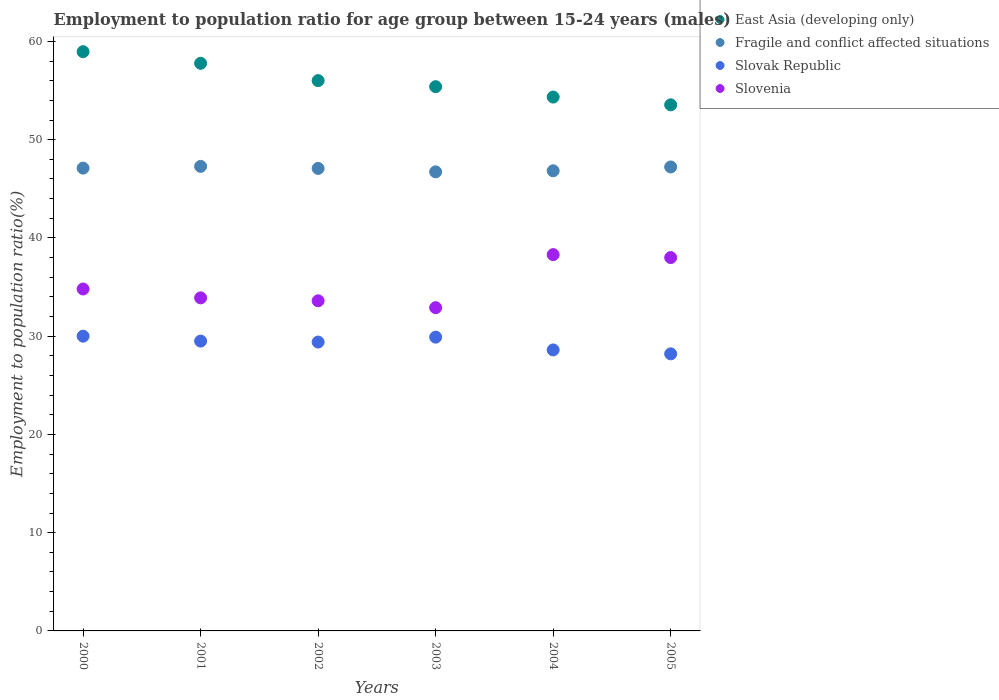What is the employment to population ratio in Slovenia in 2003?
Your response must be concise. 32.9. Across all years, what is the maximum employment to population ratio in Slovenia?
Provide a succinct answer. 38.3. Across all years, what is the minimum employment to population ratio in East Asia (developing only)?
Your answer should be very brief. 53.55. In which year was the employment to population ratio in Fragile and conflict affected situations maximum?
Your answer should be very brief. 2001. What is the total employment to population ratio in Slovenia in the graph?
Your response must be concise. 211.5. What is the difference between the employment to population ratio in Slovak Republic in 2001 and that in 2005?
Offer a very short reply. 1.3. What is the difference between the employment to population ratio in Slovak Republic in 2000 and the employment to population ratio in East Asia (developing only) in 2005?
Keep it short and to the point. -23.55. What is the average employment to population ratio in Slovak Republic per year?
Your response must be concise. 29.27. In the year 2002, what is the difference between the employment to population ratio in East Asia (developing only) and employment to population ratio in Slovenia?
Provide a short and direct response. 22.41. In how many years, is the employment to population ratio in Fragile and conflict affected situations greater than 44 %?
Ensure brevity in your answer.  6. What is the ratio of the employment to population ratio in Slovenia in 2000 to that in 2001?
Offer a very short reply. 1.03. Is the employment to population ratio in Fragile and conflict affected situations in 2000 less than that in 2004?
Your answer should be compact. No. Is the difference between the employment to population ratio in East Asia (developing only) in 2002 and 2005 greater than the difference between the employment to population ratio in Slovenia in 2002 and 2005?
Keep it short and to the point. Yes. What is the difference between the highest and the second highest employment to population ratio in Fragile and conflict affected situations?
Offer a terse response. 0.06. What is the difference between the highest and the lowest employment to population ratio in Slovenia?
Offer a very short reply. 5.4. Is the employment to population ratio in East Asia (developing only) strictly greater than the employment to population ratio in Slovak Republic over the years?
Offer a terse response. Yes. Does the graph contain grids?
Offer a very short reply. No. Where does the legend appear in the graph?
Your answer should be very brief. Top right. How many legend labels are there?
Give a very brief answer. 4. What is the title of the graph?
Your answer should be compact. Employment to population ratio for age group between 15-24 years (males). Does "Vietnam" appear as one of the legend labels in the graph?
Give a very brief answer. No. What is the label or title of the Y-axis?
Give a very brief answer. Employment to population ratio(%). What is the Employment to population ratio(%) of East Asia (developing only) in 2000?
Your answer should be very brief. 58.95. What is the Employment to population ratio(%) in Fragile and conflict affected situations in 2000?
Your answer should be compact. 47.1. What is the Employment to population ratio(%) of Slovenia in 2000?
Keep it short and to the point. 34.8. What is the Employment to population ratio(%) of East Asia (developing only) in 2001?
Keep it short and to the point. 57.77. What is the Employment to population ratio(%) in Fragile and conflict affected situations in 2001?
Ensure brevity in your answer.  47.28. What is the Employment to population ratio(%) of Slovak Republic in 2001?
Give a very brief answer. 29.5. What is the Employment to population ratio(%) of Slovenia in 2001?
Offer a terse response. 33.9. What is the Employment to population ratio(%) in East Asia (developing only) in 2002?
Your answer should be very brief. 56.01. What is the Employment to population ratio(%) in Fragile and conflict affected situations in 2002?
Keep it short and to the point. 47.07. What is the Employment to population ratio(%) of Slovak Republic in 2002?
Your answer should be very brief. 29.4. What is the Employment to population ratio(%) of Slovenia in 2002?
Make the answer very short. 33.6. What is the Employment to population ratio(%) of East Asia (developing only) in 2003?
Your response must be concise. 55.39. What is the Employment to population ratio(%) in Fragile and conflict affected situations in 2003?
Offer a terse response. 46.72. What is the Employment to population ratio(%) of Slovak Republic in 2003?
Give a very brief answer. 29.9. What is the Employment to population ratio(%) in Slovenia in 2003?
Give a very brief answer. 32.9. What is the Employment to population ratio(%) of East Asia (developing only) in 2004?
Provide a succinct answer. 54.34. What is the Employment to population ratio(%) of Fragile and conflict affected situations in 2004?
Provide a succinct answer. 46.83. What is the Employment to population ratio(%) in Slovak Republic in 2004?
Keep it short and to the point. 28.6. What is the Employment to population ratio(%) of Slovenia in 2004?
Provide a succinct answer. 38.3. What is the Employment to population ratio(%) of East Asia (developing only) in 2005?
Offer a terse response. 53.55. What is the Employment to population ratio(%) of Fragile and conflict affected situations in 2005?
Your answer should be compact. 47.22. What is the Employment to population ratio(%) of Slovak Republic in 2005?
Your answer should be compact. 28.2. What is the Employment to population ratio(%) in Slovenia in 2005?
Make the answer very short. 38. Across all years, what is the maximum Employment to population ratio(%) in East Asia (developing only)?
Give a very brief answer. 58.95. Across all years, what is the maximum Employment to population ratio(%) of Fragile and conflict affected situations?
Your answer should be very brief. 47.28. Across all years, what is the maximum Employment to population ratio(%) in Slovak Republic?
Provide a short and direct response. 30. Across all years, what is the maximum Employment to population ratio(%) in Slovenia?
Your response must be concise. 38.3. Across all years, what is the minimum Employment to population ratio(%) of East Asia (developing only)?
Make the answer very short. 53.55. Across all years, what is the minimum Employment to population ratio(%) in Fragile and conflict affected situations?
Offer a very short reply. 46.72. Across all years, what is the minimum Employment to population ratio(%) in Slovak Republic?
Ensure brevity in your answer.  28.2. Across all years, what is the minimum Employment to population ratio(%) of Slovenia?
Your response must be concise. 32.9. What is the total Employment to population ratio(%) in East Asia (developing only) in the graph?
Provide a short and direct response. 336.01. What is the total Employment to population ratio(%) in Fragile and conflict affected situations in the graph?
Make the answer very short. 282.24. What is the total Employment to population ratio(%) of Slovak Republic in the graph?
Give a very brief answer. 175.6. What is the total Employment to population ratio(%) in Slovenia in the graph?
Make the answer very short. 211.5. What is the difference between the Employment to population ratio(%) of East Asia (developing only) in 2000 and that in 2001?
Keep it short and to the point. 1.18. What is the difference between the Employment to population ratio(%) in Fragile and conflict affected situations in 2000 and that in 2001?
Provide a short and direct response. -0.18. What is the difference between the Employment to population ratio(%) of Slovak Republic in 2000 and that in 2001?
Offer a terse response. 0.5. What is the difference between the Employment to population ratio(%) of East Asia (developing only) in 2000 and that in 2002?
Offer a very short reply. 2.95. What is the difference between the Employment to population ratio(%) of Fragile and conflict affected situations in 2000 and that in 2002?
Your response must be concise. 0.03. What is the difference between the Employment to population ratio(%) of Slovenia in 2000 and that in 2002?
Make the answer very short. 1.2. What is the difference between the Employment to population ratio(%) of East Asia (developing only) in 2000 and that in 2003?
Ensure brevity in your answer.  3.56. What is the difference between the Employment to population ratio(%) of Fragile and conflict affected situations in 2000 and that in 2003?
Give a very brief answer. 0.38. What is the difference between the Employment to population ratio(%) in Slovenia in 2000 and that in 2003?
Ensure brevity in your answer.  1.9. What is the difference between the Employment to population ratio(%) in East Asia (developing only) in 2000 and that in 2004?
Make the answer very short. 4.62. What is the difference between the Employment to population ratio(%) of Fragile and conflict affected situations in 2000 and that in 2004?
Offer a very short reply. 0.27. What is the difference between the Employment to population ratio(%) of East Asia (developing only) in 2000 and that in 2005?
Give a very brief answer. 5.41. What is the difference between the Employment to population ratio(%) of Fragile and conflict affected situations in 2000 and that in 2005?
Make the answer very short. -0.12. What is the difference between the Employment to population ratio(%) of Slovak Republic in 2000 and that in 2005?
Give a very brief answer. 1.8. What is the difference between the Employment to population ratio(%) in East Asia (developing only) in 2001 and that in 2002?
Your answer should be compact. 1.76. What is the difference between the Employment to population ratio(%) in Fragile and conflict affected situations in 2001 and that in 2002?
Make the answer very short. 0.21. What is the difference between the Employment to population ratio(%) of Slovenia in 2001 and that in 2002?
Offer a very short reply. 0.3. What is the difference between the Employment to population ratio(%) of East Asia (developing only) in 2001 and that in 2003?
Keep it short and to the point. 2.38. What is the difference between the Employment to population ratio(%) in Fragile and conflict affected situations in 2001 and that in 2003?
Ensure brevity in your answer.  0.56. What is the difference between the Employment to population ratio(%) in Slovak Republic in 2001 and that in 2003?
Keep it short and to the point. -0.4. What is the difference between the Employment to population ratio(%) in East Asia (developing only) in 2001 and that in 2004?
Offer a very short reply. 3.43. What is the difference between the Employment to population ratio(%) of Fragile and conflict affected situations in 2001 and that in 2004?
Your answer should be compact. 0.45. What is the difference between the Employment to population ratio(%) in East Asia (developing only) in 2001 and that in 2005?
Offer a terse response. 4.23. What is the difference between the Employment to population ratio(%) in Fragile and conflict affected situations in 2001 and that in 2005?
Your answer should be compact. 0.06. What is the difference between the Employment to population ratio(%) in Slovak Republic in 2001 and that in 2005?
Make the answer very short. 1.3. What is the difference between the Employment to population ratio(%) of Slovenia in 2001 and that in 2005?
Offer a terse response. -4.1. What is the difference between the Employment to population ratio(%) in East Asia (developing only) in 2002 and that in 2003?
Give a very brief answer. 0.62. What is the difference between the Employment to population ratio(%) of Fragile and conflict affected situations in 2002 and that in 2003?
Offer a very short reply. 0.35. What is the difference between the Employment to population ratio(%) of Slovenia in 2002 and that in 2003?
Give a very brief answer. 0.7. What is the difference between the Employment to population ratio(%) in East Asia (developing only) in 2002 and that in 2004?
Give a very brief answer. 1.67. What is the difference between the Employment to population ratio(%) of Fragile and conflict affected situations in 2002 and that in 2004?
Provide a succinct answer. 0.24. What is the difference between the Employment to population ratio(%) of Slovak Republic in 2002 and that in 2004?
Offer a very short reply. 0.8. What is the difference between the Employment to population ratio(%) of East Asia (developing only) in 2002 and that in 2005?
Give a very brief answer. 2.46. What is the difference between the Employment to population ratio(%) of Fragile and conflict affected situations in 2002 and that in 2005?
Make the answer very short. -0.15. What is the difference between the Employment to population ratio(%) of East Asia (developing only) in 2003 and that in 2004?
Offer a very short reply. 1.06. What is the difference between the Employment to population ratio(%) in Fragile and conflict affected situations in 2003 and that in 2004?
Keep it short and to the point. -0.11. What is the difference between the Employment to population ratio(%) of Slovenia in 2003 and that in 2004?
Offer a terse response. -5.4. What is the difference between the Employment to population ratio(%) in East Asia (developing only) in 2003 and that in 2005?
Ensure brevity in your answer.  1.85. What is the difference between the Employment to population ratio(%) of Fragile and conflict affected situations in 2003 and that in 2005?
Provide a short and direct response. -0.5. What is the difference between the Employment to population ratio(%) of Slovak Republic in 2003 and that in 2005?
Provide a short and direct response. 1.7. What is the difference between the Employment to population ratio(%) of Slovenia in 2003 and that in 2005?
Make the answer very short. -5.1. What is the difference between the Employment to population ratio(%) of East Asia (developing only) in 2004 and that in 2005?
Give a very brief answer. 0.79. What is the difference between the Employment to population ratio(%) of Fragile and conflict affected situations in 2004 and that in 2005?
Provide a succinct answer. -0.39. What is the difference between the Employment to population ratio(%) in Slovak Republic in 2004 and that in 2005?
Give a very brief answer. 0.4. What is the difference between the Employment to population ratio(%) in Slovenia in 2004 and that in 2005?
Give a very brief answer. 0.3. What is the difference between the Employment to population ratio(%) of East Asia (developing only) in 2000 and the Employment to population ratio(%) of Fragile and conflict affected situations in 2001?
Provide a succinct answer. 11.67. What is the difference between the Employment to population ratio(%) in East Asia (developing only) in 2000 and the Employment to population ratio(%) in Slovak Republic in 2001?
Give a very brief answer. 29.45. What is the difference between the Employment to population ratio(%) of East Asia (developing only) in 2000 and the Employment to population ratio(%) of Slovenia in 2001?
Keep it short and to the point. 25.05. What is the difference between the Employment to population ratio(%) of Fragile and conflict affected situations in 2000 and the Employment to population ratio(%) of Slovak Republic in 2001?
Your answer should be very brief. 17.6. What is the difference between the Employment to population ratio(%) of Fragile and conflict affected situations in 2000 and the Employment to population ratio(%) of Slovenia in 2001?
Your answer should be compact. 13.2. What is the difference between the Employment to population ratio(%) of Slovak Republic in 2000 and the Employment to population ratio(%) of Slovenia in 2001?
Your response must be concise. -3.9. What is the difference between the Employment to population ratio(%) in East Asia (developing only) in 2000 and the Employment to population ratio(%) in Fragile and conflict affected situations in 2002?
Keep it short and to the point. 11.88. What is the difference between the Employment to population ratio(%) of East Asia (developing only) in 2000 and the Employment to population ratio(%) of Slovak Republic in 2002?
Offer a very short reply. 29.55. What is the difference between the Employment to population ratio(%) of East Asia (developing only) in 2000 and the Employment to population ratio(%) of Slovenia in 2002?
Provide a succinct answer. 25.35. What is the difference between the Employment to population ratio(%) in Fragile and conflict affected situations in 2000 and the Employment to population ratio(%) in Slovak Republic in 2002?
Make the answer very short. 17.7. What is the difference between the Employment to population ratio(%) in Fragile and conflict affected situations in 2000 and the Employment to population ratio(%) in Slovenia in 2002?
Your response must be concise. 13.5. What is the difference between the Employment to population ratio(%) of East Asia (developing only) in 2000 and the Employment to population ratio(%) of Fragile and conflict affected situations in 2003?
Offer a terse response. 12.23. What is the difference between the Employment to population ratio(%) of East Asia (developing only) in 2000 and the Employment to population ratio(%) of Slovak Republic in 2003?
Provide a short and direct response. 29.05. What is the difference between the Employment to population ratio(%) in East Asia (developing only) in 2000 and the Employment to population ratio(%) in Slovenia in 2003?
Keep it short and to the point. 26.05. What is the difference between the Employment to population ratio(%) in Fragile and conflict affected situations in 2000 and the Employment to population ratio(%) in Slovak Republic in 2003?
Keep it short and to the point. 17.2. What is the difference between the Employment to population ratio(%) in Fragile and conflict affected situations in 2000 and the Employment to population ratio(%) in Slovenia in 2003?
Your answer should be very brief. 14.2. What is the difference between the Employment to population ratio(%) of Slovak Republic in 2000 and the Employment to population ratio(%) of Slovenia in 2003?
Give a very brief answer. -2.9. What is the difference between the Employment to population ratio(%) of East Asia (developing only) in 2000 and the Employment to population ratio(%) of Fragile and conflict affected situations in 2004?
Provide a succinct answer. 12.12. What is the difference between the Employment to population ratio(%) of East Asia (developing only) in 2000 and the Employment to population ratio(%) of Slovak Republic in 2004?
Give a very brief answer. 30.35. What is the difference between the Employment to population ratio(%) in East Asia (developing only) in 2000 and the Employment to population ratio(%) in Slovenia in 2004?
Your answer should be compact. 20.65. What is the difference between the Employment to population ratio(%) in Fragile and conflict affected situations in 2000 and the Employment to population ratio(%) in Slovak Republic in 2004?
Keep it short and to the point. 18.5. What is the difference between the Employment to population ratio(%) of Fragile and conflict affected situations in 2000 and the Employment to population ratio(%) of Slovenia in 2004?
Your answer should be compact. 8.8. What is the difference between the Employment to population ratio(%) in Slovak Republic in 2000 and the Employment to population ratio(%) in Slovenia in 2004?
Offer a terse response. -8.3. What is the difference between the Employment to population ratio(%) in East Asia (developing only) in 2000 and the Employment to population ratio(%) in Fragile and conflict affected situations in 2005?
Provide a succinct answer. 11.73. What is the difference between the Employment to population ratio(%) in East Asia (developing only) in 2000 and the Employment to population ratio(%) in Slovak Republic in 2005?
Your response must be concise. 30.75. What is the difference between the Employment to population ratio(%) of East Asia (developing only) in 2000 and the Employment to population ratio(%) of Slovenia in 2005?
Your answer should be compact. 20.95. What is the difference between the Employment to population ratio(%) in Fragile and conflict affected situations in 2000 and the Employment to population ratio(%) in Slovak Republic in 2005?
Provide a succinct answer. 18.9. What is the difference between the Employment to population ratio(%) in Fragile and conflict affected situations in 2000 and the Employment to population ratio(%) in Slovenia in 2005?
Keep it short and to the point. 9.1. What is the difference between the Employment to population ratio(%) in Slovak Republic in 2000 and the Employment to population ratio(%) in Slovenia in 2005?
Offer a very short reply. -8. What is the difference between the Employment to population ratio(%) of East Asia (developing only) in 2001 and the Employment to population ratio(%) of Fragile and conflict affected situations in 2002?
Make the answer very short. 10.7. What is the difference between the Employment to population ratio(%) in East Asia (developing only) in 2001 and the Employment to population ratio(%) in Slovak Republic in 2002?
Give a very brief answer. 28.37. What is the difference between the Employment to population ratio(%) in East Asia (developing only) in 2001 and the Employment to population ratio(%) in Slovenia in 2002?
Ensure brevity in your answer.  24.17. What is the difference between the Employment to population ratio(%) in Fragile and conflict affected situations in 2001 and the Employment to population ratio(%) in Slovak Republic in 2002?
Your response must be concise. 17.88. What is the difference between the Employment to population ratio(%) in Fragile and conflict affected situations in 2001 and the Employment to population ratio(%) in Slovenia in 2002?
Provide a short and direct response. 13.68. What is the difference between the Employment to population ratio(%) of Slovak Republic in 2001 and the Employment to population ratio(%) of Slovenia in 2002?
Keep it short and to the point. -4.1. What is the difference between the Employment to population ratio(%) in East Asia (developing only) in 2001 and the Employment to population ratio(%) in Fragile and conflict affected situations in 2003?
Provide a short and direct response. 11.05. What is the difference between the Employment to population ratio(%) in East Asia (developing only) in 2001 and the Employment to population ratio(%) in Slovak Republic in 2003?
Your answer should be very brief. 27.87. What is the difference between the Employment to population ratio(%) in East Asia (developing only) in 2001 and the Employment to population ratio(%) in Slovenia in 2003?
Provide a succinct answer. 24.87. What is the difference between the Employment to population ratio(%) of Fragile and conflict affected situations in 2001 and the Employment to population ratio(%) of Slovak Republic in 2003?
Keep it short and to the point. 17.38. What is the difference between the Employment to population ratio(%) of Fragile and conflict affected situations in 2001 and the Employment to population ratio(%) of Slovenia in 2003?
Keep it short and to the point. 14.38. What is the difference between the Employment to population ratio(%) of Slovak Republic in 2001 and the Employment to population ratio(%) of Slovenia in 2003?
Ensure brevity in your answer.  -3.4. What is the difference between the Employment to population ratio(%) in East Asia (developing only) in 2001 and the Employment to population ratio(%) in Fragile and conflict affected situations in 2004?
Ensure brevity in your answer.  10.94. What is the difference between the Employment to population ratio(%) in East Asia (developing only) in 2001 and the Employment to population ratio(%) in Slovak Republic in 2004?
Make the answer very short. 29.17. What is the difference between the Employment to population ratio(%) of East Asia (developing only) in 2001 and the Employment to population ratio(%) of Slovenia in 2004?
Make the answer very short. 19.47. What is the difference between the Employment to population ratio(%) of Fragile and conflict affected situations in 2001 and the Employment to population ratio(%) of Slovak Republic in 2004?
Provide a succinct answer. 18.68. What is the difference between the Employment to population ratio(%) in Fragile and conflict affected situations in 2001 and the Employment to population ratio(%) in Slovenia in 2004?
Ensure brevity in your answer.  8.98. What is the difference between the Employment to population ratio(%) in Slovak Republic in 2001 and the Employment to population ratio(%) in Slovenia in 2004?
Your answer should be very brief. -8.8. What is the difference between the Employment to population ratio(%) in East Asia (developing only) in 2001 and the Employment to population ratio(%) in Fragile and conflict affected situations in 2005?
Offer a terse response. 10.55. What is the difference between the Employment to population ratio(%) in East Asia (developing only) in 2001 and the Employment to population ratio(%) in Slovak Republic in 2005?
Offer a terse response. 29.57. What is the difference between the Employment to population ratio(%) in East Asia (developing only) in 2001 and the Employment to population ratio(%) in Slovenia in 2005?
Offer a terse response. 19.77. What is the difference between the Employment to population ratio(%) of Fragile and conflict affected situations in 2001 and the Employment to population ratio(%) of Slovak Republic in 2005?
Provide a short and direct response. 19.08. What is the difference between the Employment to population ratio(%) in Fragile and conflict affected situations in 2001 and the Employment to population ratio(%) in Slovenia in 2005?
Give a very brief answer. 9.28. What is the difference between the Employment to population ratio(%) in East Asia (developing only) in 2002 and the Employment to population ratio(%) in Fragile and conflict affected situations in 2003?
Provide a succinct answer. 9.29. What is the difference between the Employment to population ratio(%) of East Asia (developing only) in 2002 and the Employment to population ratio(%) of Slovak Republic in 2003?
Give a very brief answer. 26.11. What is the difference between the Employment to population ratio(%) of East Asia (developing only) in 2002 and the Employment to population ratio(%) of Slovenia in 2003?
Offer a very short reply. 23.11. What is the difference between the Employment to population ratio(%) in Fragile and conflict affected situations in 2002 and the Employment to population ratio(%) in Slovak Republic in 2003?
Provide a short and direct response. 17.17. What is the difference between the Employment to population ratio(%) of Fragile and conflict affected situations in 2002 and the Employment to population ratio(%) of Slovenia in 2003?
Keep it short and to the point. 14.17. What is the difference between the Employment to population ratio(%) in East Asia (developing only) in 2002 and the Employment to population ratio(%) in Fragile and conflict affected situations in 2004?
Keep it short and to the point. 9.18. What is the difference between the Employment to population ratio(%) of East Asia (developing only) in 2002 and the Employment to population ratio(%) of Slovak Republic in 2004?
Provide a short and direct response. 27.41. What is the difference between the Employment to population ratio(%) of East Asia (developing only) in 2002 and the Employment to population ratio(%) of Slovenia in 2004?
Offer a terse response. 17.71. What is the difference between the Employment to population ratio(%) of Fragile and conflict affected situations in 2002 and the Employment to population ratio(%) of Slovak Republic in 2004?
Make the answer very short. 18.47. What is the difference between the Employment to population ratio(%) in Fragile and conflict affected situations in 2002 and the Employment to population ratio(%) in Slovenia in 2004?
Offer a terse response. 8.77. What is the difference between the Employment to population ratio(%) of East Asia (developing only) in 2002 and the Employment to population ratio(%) of Fragile and conflict affected situations in 2005?
Your answer should be compact. 8.79. What is the difference between the Employment to population ratio(%) of East Asia (developing only) in 2002 and the Employment to population ratio(%) of Slovak Republic in 2005?
Your answer should be very brief. 27.81. What is the difference between the Employment to population ratio(%) of East Asia (developing only) in 2002 and the Employment to population ratio(%) of Slovenia in 2005?
Your answer should be compact. 18.01. What is the difference between the Employment to population ratio(%) of Fragile and conflict affected situations in 2002 and the Employment to population ratio(%) of Slovak Republic in 2005?
Give a very brief answer. 18.87. What is the difference between the Employment to population ratio(%) in Fragile and conflict affected situations in 2002 and the Employment to population ratio(%) in Slovenia in 2005?
Make the answer very short. 9.07. What is the difference between the Employment to population ratio(%) of East Asia (developing only) in 2003 and the Employment to population ratio(%) of Fragile and conflict affected situations in 2004?
Make the answer very short. 8.56. What is the difference between the Employment to population ratio(%) of East Asia (developing only) in 2003 and the Employment to population ratio(%) of Slovak Republic in 2004?
Offer a very short reply. 26.79. What is the difference between the Employment to population ratio(%) of East Asia (developing only) in 2003 and the Employment to population ratio(%) of Slovenia in 2004?
Offer a very short reply. 17.09. What is the difference between the Employment to population ratio(%) of Fragile and conflict affected situations in 2003 and the Employment to population ratio(%) of Slovak Republic in 2004?
Your answer should be very brief. 18.12. What is the difference between the Employment to population ratio(%) of Fragile and conflict affected situations in 2003 and the Employment to population ratio(%) of Slovenia in 2004?
Offer a terse response. 8.42. What is the difference between the Employment to population ratio(%) of East Asia (developing only) in 2003 and the Employment to population ratio(%) of Fragile and conflict affected situations in 2005?
Keep it short and to the point. 8.17. What is the difference between the Employment to population ratio(%) in East Asia (developing only) in 2003 and the Employment to population ratio(%) in Slovak Republic in 2005?
Ensure brevity in your answer.  27.19. What is the difference between the Employment to population ratio(%) in East Asia (developing only) in 2003 and the Employment to population ratio(%) in Slovenia in 2005?
Make the answer very short. 17.39. What is the difference between the Employment to population ratio(%) in Fragile and conflict affected situations in 2003 and the Employment to population ratio(%) in Slovak Republic in 2005?
Your answer should be very brief. 18.52. What is the difference between the Employment to population ratio(%) of Fragile and conflict affected situations in 2003 and the Employment to population ratio(%) of Slovenia in 2005?
Give a very brief answer. 8.72. What is the difference between the Employment to population ratio(%) of Slovak Republic in 2003 and the Employment to population ratio(%) of Slovenia in 2005?
Your answer should be very brief. -8.1. What is the difference between the Employment to population ratio(%) of East Asia (developing only) in 2004 and the Employment to population ratio(%) of Fragile and conflict affected situations in 2005?
Ensure brevity in your answer.  7.11. What is the difference between the Employment to population ratio(%) of East Asia (developing only) in 2004 and the Employment to population ratio(%) of Slovak Republic in 2005?
Your answer should be compact. 26.14. What is the difference between the Employment to population ratio(%) of East Asia (developing only) in 2004 and the Employment to population ratio(%) of Slovenia in 2005?
Provide a succinct answer. 16.34. What is the difference between the Employment to population ratio(%) in Fragile and conflict affected situations in 2004 and the Employment to population ratio(%) in Slovak Republic in 2005?
Your answer should be compact. 18.63. What is the difference between the Employment to population ratio(%) of Fragile and conflict affected situations in 2004 and the Employment to population ratio(%) of Slovenia in 2005?
Offer a terse response. 8.83. What is the average Employment to population ratio(%) in East Asia (developing only) per year?
Offer a very short reply. 56. What is the average Employment to population ratio(%) of Fragile and conflict affected situations per year?
Offer a terse response. 47.04. What is the average Employment to population ratio(%) in Slovak Republic per year?
Provide a short and direct response. 29.27. What is the average Employment to population ratio(%) in Slovenia per year?
Offer a terse response. 35.25. In the year 2000, what is the difference between the Employment to population ratio(%) of East Asia (developing only) and Employment to population ratio(%) of Fragile and conflict affected situations?
Your answer should be compact. 11.85. In the year 2000, what is the difference between the Employment to population ratio(%) in East Asia (developing only) and Employment to population ratio(%) in Slovak Republic?
Your answer should be very brief. 28.95. In the year 2000, what is the difference between the Employment to population ratio(%) in East Asia (developing only) and Employment to population ratio(%) in Slovenia?
Give a very brief answer. 24.15. In the year 2000, what is the difference between the Employment to population ratio(%) in Fragile and conflict affected situations and Employment to population ratio(%) in Slovak Republic?
Provide a succinct answer. 17.1. In the year 2000, what is the difference between the Employment to population ratio(%) of Fragile and conflict affected situations and Employment to population ratio(%) of Slovenia?
Provide a succinct answer. 12.3. In the year 2001, what is the difference between the Employment to population ratio(%) in East Asia (developing only) and Employment to population ratio(%) in Fragile and conflict affected situations?
Offer a very short reply. 10.49. In the year 2001, what is the difference between the Employment to population ratio(%) of East Asia (developing only) and Employment to population ratio(%) of Slovak Republic?
Give a very brief answer. 28.27. In the year 2001, what is the difference between the Employment to population ratio(%) in East Asia (developing only) and Employment to population ratio(%) in Slovenia?
Give a very brief answer. 23.87. In the year 2001, what is the difference between the Employment to population ratio(%) of Fragile and conflict affected situations and Employment to population ratio(%) of Slovak Republic?
Provide a short and direct response. 17.78. In the year 2001, what is the difference between the Employment to population ratio(%) of Fragile and conflict affected situations and Employment to population ratio(%) of Slovenia?
Your response must be concise. 13.38. In the year 2001, what is the difference between the Employment to population ratio(%) in Slovak Republic and Employment to population ratio(%) in Slovenia?
Keep it short and to the point. -4.4. In the year 2002, what is the difference between the Employment to population ratio(%) of East Asia (developing only) and Employment to population ratio(%) of Fragile and conflict affected situations?
Offer a terse response. 8.94. In the year 2002, what is the difference between the Employment to population ratio(%) in East Asia (developing only) and Employment to population ratio(%) in Slovak Republic?
Ensure brevity in your answer.  26.61. In the year 2002, what is the difference between the Employment to population ratio(%) of East Asia (developing only) and Employment to population ratio(%) of Slovenia?
Make the answer very short. 22.41. In the year 2002, what is the difference between the Employment to population ratio(%) in Fragile and conflict affected situations and Employment to population ratio(%) in Slovak Republic?
Your answer should be very brief. 17.67. In the year 2002, what is the difference between the Employment to population ratio(%) of Fragile and conflict affected situations and Employment to population ratio(%) of Slovenia?
Make the answer very short. 13.47. In the year 2003, what is the difference between the Employment to population ratio(%) of East Asia (developing only) and Employment to population ratio(%) of Fragile and conflict affected situations?
Provide a short and direct response. 8.67. In the year 2003, what is the difference between the Employment to population ratio(%) in East Asia (developing only) and Employment to population ratio(%) in Slovak Republic?
Your answer should be compact. 25.49. In the year 2003, what is the difference between the Employment to population ratio(%) in East Asia (developing only) and Employment to population ratio(%) in Slovenia?
Give a very brief answer. 22.49. In the year 2003, what is the difference between the Employment to population ratio(%) of Fragile and conflict affected situations and Employment to population ratio(%) of Slovak Republic?
Provide a short and direct response. 16.82. In the year 2003, what is the difference between the Employment to population ratio(%) in Fragile and conflict affected situations and Employment to population ratio(%) in Slovenia?
Provide a short and direct response. 13.82. In the year 2003, what is the difference between the Employment to population ratio(%) of Slovak Republic and Employment to population ratio(%) of Slovenia?
Ensure brevity in your answer.  -3. In the year 2004, what is the difference between the Employment to population ratio(%) in East Asia (developing only) and Employment to population ratio(%) in Fragile and conflict affected situations?
Provide a short and direct response. 7.51. In the year 2004, what is the difference between the Employment to population ratio(%) in East Asia (developing only) and Employment to population ratio(%) in Slovak Republic?
Your response must be concise. 25.74. In the year 2004, what is the difference between the Employment to population ratio(%) of East Asia (developing only) and Employment to population ratio(%) of Slovenia?
Keep it short and to the point. 16.04. In the year 2004, what is the difference between the Employment to population ratio(%) of Fragile and conflict affected situations and Employment to population ratio(%) of Slovak Republic?
Your response must be concise. 18.23. In the year 2004, what is the difference between the Employment to population ratio(%) in Fragile and conflict affected situations and Employment to population ratio(%) in Slovenia?
Make the answer very short. 8.53. In the year 2004, what is the difference between the Employment to population ratio(%) in Slovak Republic and Employment to population ratio(%) in Slovenia?
Your answer should be very brief. -9.7. In the year 2005, what is the difference between the Employment to population ratio(%) of East Asia (developing only) and Employment to population ratio(%) of Fragile and conflict affected situations?
Make the answer very short. 6.32. In the year 2005, what is the difference between the Employment to population ratio(%) in East Asia (developing only) and Employment to population ratio(%) in Slovak Republic?
Give a very brief answer. 25.34. In the year 2005, what is the difference between the Employment to population ratio(%) of East Asia (developing only) and Employment to population ratio(%) of Slovenia?
Give a very brief answer. 15.54. In the year 2005, what is the difference between the Employment to population ratio(%) in Fragile and conflict affected situations and Employment to population ratio(%) in Slovak Republic?
Keep it short and to the point. 19.02. In the year 2005, what is the difference between the Employment to population ratio(%) in Fragile and conflict affected situations and Employment to population ratio(%) in Slovenia?
Your response must be concise. 9.22. In the year 2005, what is the difference between the Employment to population ratio(%) in Slovak Republic and Employment to population ratio(%) in Slovenia?
Offer a terse response. -9.8. What is the ratio of the Employment to population ratio(%) of East Asia (developing only) in 2000 to that in 2001?
Provide a short and direct response. 1.02. What is the ratio of the Employment to population ratio(%) of Fragile and conflict affected situations in 2000 to that in 2001?
Give a very brief answer. 1. What is the ratio of the Employment to population ratio(%) in Slovak Republic in 2000 to that in 2001?
Give a very brief answer. 1.02. What is the ratio of the Employment to population ratio(%) of Slovenia in 2000 to that in 2001?
Offer a terse response. 1.03. What is the ratio of the Employment to population ratio(%) of East Asia (developing only) in 2000 to that in 2002?
Offer a very short reply. 1.05. What is the ratio of the Employment to population ratio(%) of Slovak Republic in 2000 to that in 2002?
Give a very brief answer. 1.02. What is the ratio of the Employment to population ratio(%) in Slovenia in 2000 to that in 2002?
Provide a short and direct response. 1.04. What is the ratio of the Employment to population ratio(%) of East Asia (developing only) in 2000 to that in 2003?
Keep it short and to the point. 1.06. What is the ratio of the Employment to population ratio(%) in Slovak Republic in 2000 to that in 2003?
Make the answer very short. 1. What is the ratio of the Employment to population ratio(%) in Slovenia in 2000 to that in 2003?
Your answer should be compact. 1.06. What is the ratio of the Employment to population ratio(%) of East Asia (developing only) in 2000 to that in 2004?
Give a very brief answer. 1.08. What is the ratio of the Employment to population ratio(%) in Fragile and conflict affected situations in 2000 to that in 2004?
Provide a short and direct response. 1.01. What is the ratio of the Employment to population ratio(%) in Slovak Republic in 2000 to that in 2004?
Make the answer very short. 1.05. What is the ratio of the Employment to population ratio(%) in Slovenia in 2000 to that in 2004?
Your answer should be compact. 0.91. What is the ratio of the Employment to population ratio(%) of East Asia (developing only) in 2000 to that in 2005?
Offer a very short reply. 1.1. What is the ratio of the Employment to population ratio(%) of Fragile and conflict affected situations in 2000 to that in 2005?
Ensure brevity in your answer.  1. What is the ratio of the Employment to population ratio(%) of Slovak Republic in 2000 to that in 2005?
Provide a short and direct response. 1.06. What is the ratio of the Employment to population ratio(%) of Slovenia in 2000 to that in 2005?
Your answer should be very brief. 0.92. What is the ratio of the Employment to population ratio(%) in East Asia (developing only) in 2001 to that in 2002?
Your answer should be compact. 1.03. What is the ratio of the Employment to population ratio(%) in Fragile and conflict affected situations in 2001 to that in 2002?
Your answer should be compact. 1. What is the ratio of the Employment to population ratio(%) of Slovenia in 2001 to that in 2002?
Provide a succinct answer. 1.01. What is the ratio of the Employment to population ratio(%) in East Asia (developing only) in 2001 to that in 2003?
Provide a short and direct response. 1.04. What is the ratio of the Employment to population ratio(%) of Fragile and conflict affected situations in 2001 to that in 2003?
Provide a short and direct response. 1.01. What is the ratio of the Employment to population ratio(%) in Slovak Republic in 2001 to that in 2003?
Provide a succinct answer. 0.99. What is the ratio of the Employment to population ratio(%) of Slovenia in 2001 to that in 2003?
Your answer should be very brief. 1.03. What is the ratio of the Employment to population ratio(%) of East Asia (developing only) in 2001 to that in 2004?
Provide a succinct answer. 1.06. What is the ratio of the Employment to population ratio(%) in Fragile and conflict affected situations in 2001 to that in 2004?
Provide a short and direct response. 1.01. What is the ratio of the Employment to population ratio(%) of Slovak Republic in 2001 to that in 2004?
Ensure brevity in your answer.  1.03. What is the ratio of the Employment to population ratio(%) in Slovenia in 2001 to that in 2004?
Your answer should be compact. 0.89. What is the ratio of the Employment to population ratio(%) in East Asia (developing only) in 2001 to that in 2005?
Provide a succinct answer. 1.08. What is the ratio of the Employment to population ratio(%) of Fragile and conflict affected situations in 2001 to that in 2005?
Give a very brief answer. 1. What is the ratio of the Employment to population ratio(%) of Slovak Republic in 2001 to that in 2005?
Give a very brief answer. 1.05. What is the ratio of the Employment to population ratio(%) in Slovenia in 2001 to that in 2005?
Offer a terse response. 0.89. What is the ratio of the Employment to population ratio(%) in East Asia (developing only) in 2002 to that in 2003?
Provide a succinct answer. 1.01. What is the ratio of the Employment to population ratio(%) in Fragile and conflict affected situations in 2002 to that in 2003?
Offer a terse response. 1.01. What is the ratio of the Employment to population ratio(%) of Slovak Republic in 2002 to that in 2003?
Provide a succinct answer. 0.98. What is the ratio of the Employment to population ratio(%) in Slovenia in 2002 to that in 2003?
Offer a very short reply. 1.02. What is the ratio of the Employment to population ratio(%) of East Asia (developing only) in 2002 to that in 2004?
Offer a terse response. 1.03. What is the ratio of the Employment to population ratio(%) of Fragile and conflict affected situations in 2002 to that in 2004?
Your answer should be compact. 1.01. What is the ratio of the Employment to population ratio(%) in Slovak Republic in 2002 to that in 2004?
Ensure brevity in your answer.  1.03. What is the ratio of the Employment to population ratio(%) of Slovenia in 2002 to that in 2004?
Give a very brief answer. 0.88. What is the ratio of the Employment to population ratio(%) of East Asia (developing only) in 2002 to that in 2005?
Provide a succinct answer. 1.05. What is the ratio of the Employment to population ratio(%) of Slovak Republic in 2002 to that in 2005?
Your answer should be compact. 1.04. What is the ratio of the Employment to population ratio(%) of Slovenia in 2002 to that in 2005?
Make the answer very short. 0.88. What is the ratio of the Employment to population ratio(%) of East Asia (developing only) in 2003 to that in 2004?
Make the answer very short. 1.02. What is the ratio of the Employment to population ratio(%) in Slovak Republic in 2003 to that in 2004?
Provide a succinct answer. 1.05. What is the ratio of the Employment to population ratio(%) of Slovenia in 2003 to that in 2004?
Provide a short and direct response. 0.86. What is the ratio of the Employment to population ratio(%) in East Asia (developing only) in 2003 to that in 2005?
Provide a succinct answer. 1.03. What is the ratio of the Employment to population ratio(%) in Slovak Republic in 2003 to that in 2005?
Your answer should be compact. 1.06. What is the ratio of the Employment to population ratio(%) of Slovenia in 2003 to that in 2005?
Ensure brevity in your answer.  0.87. What is the ratio of the Employment to population ratio(%) of East Asia (developing only) in 2004 to that in 2005?
Offer a very short reply. 1.01. What is the ratio of the Employment to population ratio(%) in Fragile and conflict affected situations in 2004 to that in 2005?
Give a very brief answer. 0.99. What is the ratio of the Employment to population ratio(%) in Slovak Republic in 2004 to that in 2005?
Keep it short and to the point. 1.01. What is the ratio of the Employment to population ratio(%) in Slovenia in 2004 to that in 2005?
Provide a succinct answer. 1.01. What is the difference between the highest and the second highest Employment to population ratio(%) in East Asia (developing only)?
Give a very brief answer. 1.18. What is the difference between the highest and the second highest Employment to population ratio(%) in Fragile and conflict affected situations?
Offer a very short reply. 0.06. What is the difference between the highest and the second highest Employment to population ratio(%) of Slovak Republic?
Make the answer very short. 0.1. What is the difference between the highest and the lowest Employment to population ratio(%) in East Asia (developing only)?
Your answer should be compact. 5.41. What is the difference between the highest and the lowest Employment to population ratio(%) of Fragile and conflict affected situations?
Keep it short and to the point. 0.56. What is the difference between the highest and the lowest Employment to population ratio(%) of Slovak Republic?
Make the answer very short. 1.8. 